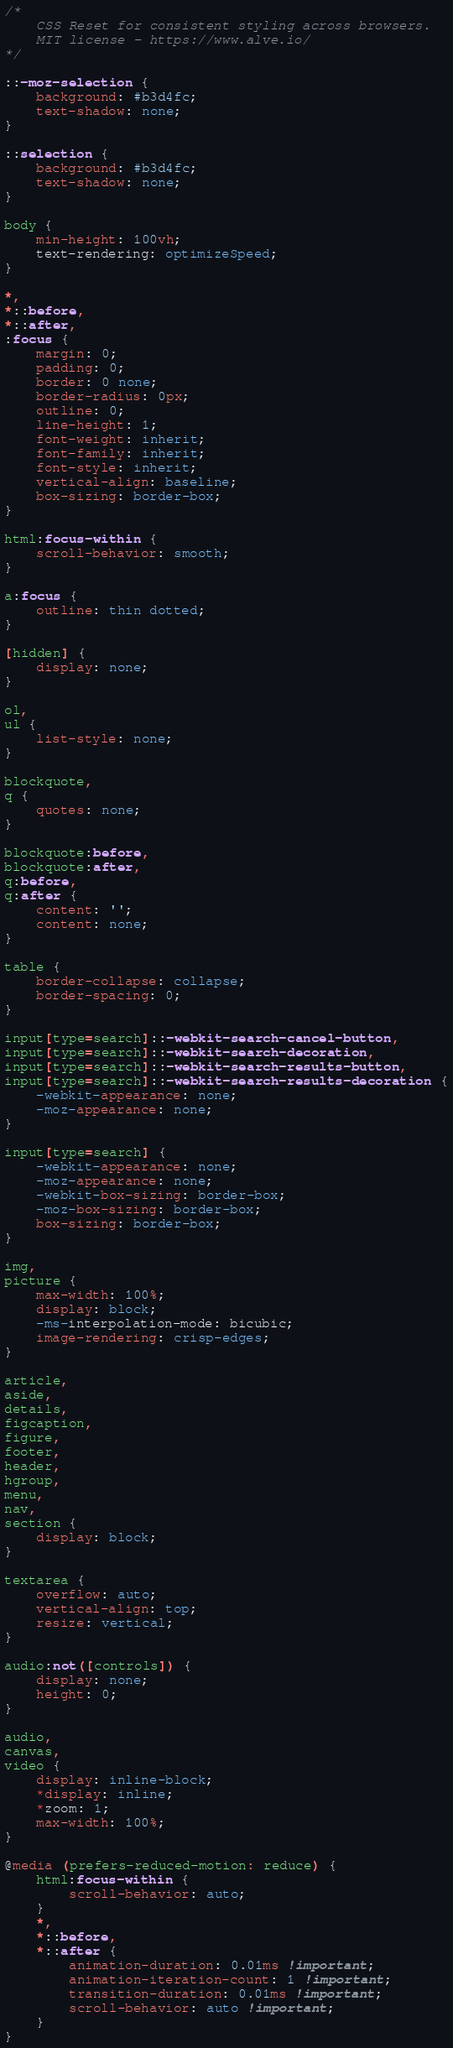<code> <loc_0><loc_0><loc_500><loc_500><_CSS_>/*
    CSS Reset for consistent styling across browsers.
    MIT license - https://www.alve.io/
*/

::-moz-selection {
    background: #b3d4fc;
    text-shadow: none;
}

::selection {
    background: #b3d4fc;
    text-shadow: none;
}

body {
    min-height: 100vh;
    text-rendering: optimizeSpeed;
}

*,
*::before,
*::after,
:focus {
    margin: 0;
    padding: 0;
    border: 0 none;
    border-radius: 0px;
    outline: 0;
    line-height: 1;
    font-weight: inherit;
    font-family: inherit;
    font-style: inherit;
    vertical-align: baseline;
    box-sizing: border-box;
}

html:focus-within {
    scroll-behavior: smooth;
}

a:focus {
    outline: thin dotted;
}

[hidden] {
    display: none;
}

ol,
ul {
    list-style: none;
}

blockquote,
q {
    quotes: none;
}

blockquote:before,
blockquote:after,
q:before,
q:after {
    content: '';
    content: none;
}

table {
    border-collapse: collapse;
    border-spacing: 0;
}

input[type=search]::-webkit-search-cancel-button,
input[type=search]::-webkit-search-decoration,
input[type=search]::-webkit-search-results-button,
input[type=search]::-webkit-search-results-decoration {
    -webkit-appearance: none;
    -moz-appearance: none;
}

input[type=search] {
    -webkit-appearance: none;
    -moz-appearance: none;
    -webkit-box-sizing: border-box;
    -moz-box-sizing: border-box;
    box-sizing: border-box;
}

img,
picture {
    max-width: 100%;
    display: block;
    -ms-interpolation-mode: bicubic;
    image-rendering: crisp-edges;
}

article,
aside,
details,
figcaption,
figure,
footer,
header,
hgroup,
menu,
nav,
section {
    display: block;
}

textarea {
    overflow: auto;
    vertical-align: top;
    resize: vertical;
}

audio:not([controls]) {
    display: none;
    height: 0;
}

audio,
canvas,
video {
    display: inline-block;
    *display: inline;
    *zoom: 1;
    max-width: 100%;
}

@media (prefers-reduced-motion: reduce) {
    html:focus-within {
        scroll-behavior: auto;
    }
    *,
    *::before,
    *::after {
        animation-duration: 0.01ms !important;
        animation-iteration-count: 1 !important;
        transition-duration: 0.01ms !important;
        scroll-behavior: auto !important;
    }
}</code> 